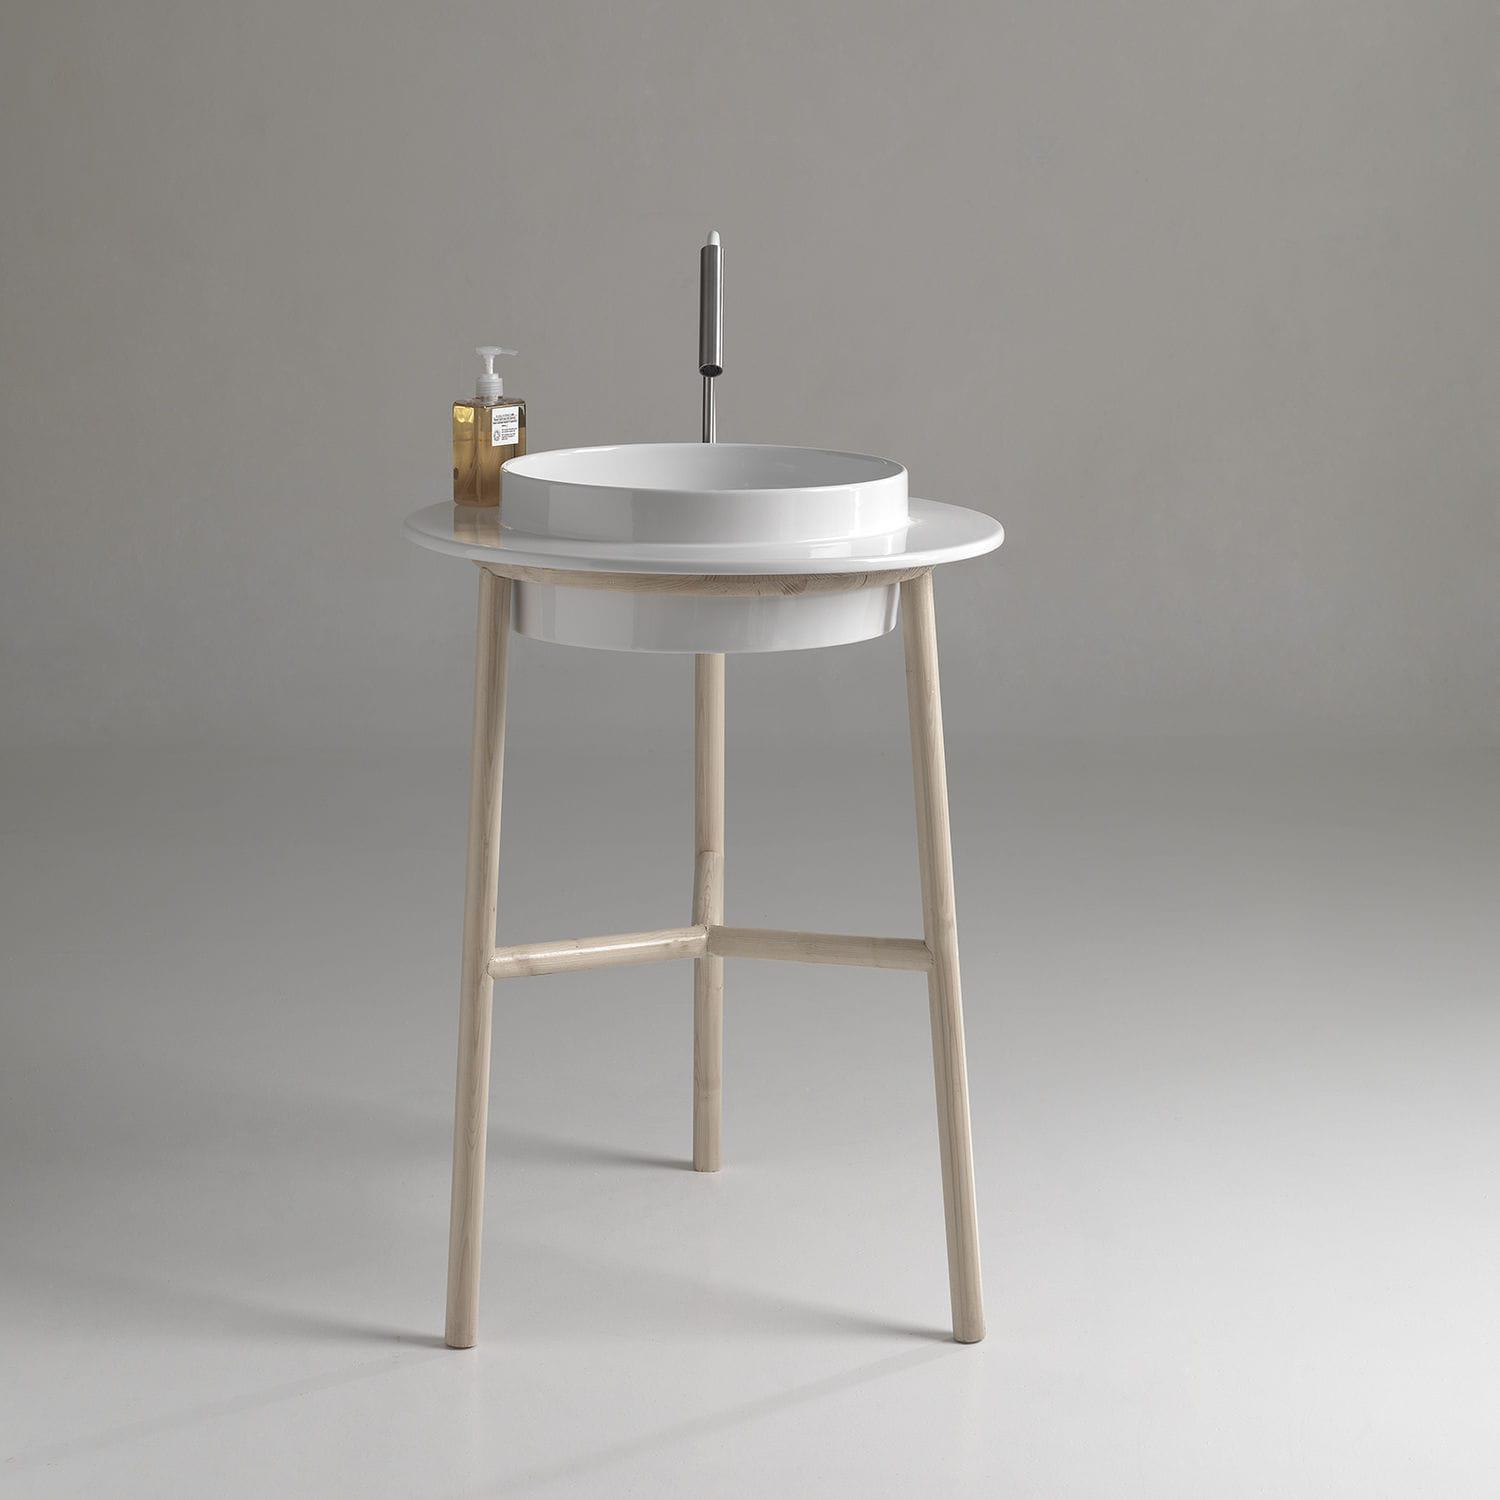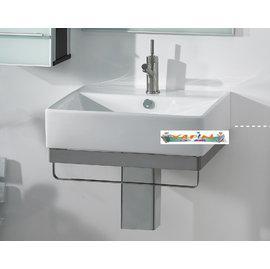The first image is the image on the left, the second image is the image on the right. Considering the images on both sides, is "One sink is round shaped." valid? Answer yes or no. Yes. The first image is the image on the left, the second image is the image on the right. For the images shown, is this caption "One image shows a rectangular sink supported by two metal legs, with a horizontal bar along three sides." true? Answer yes or no. No. 